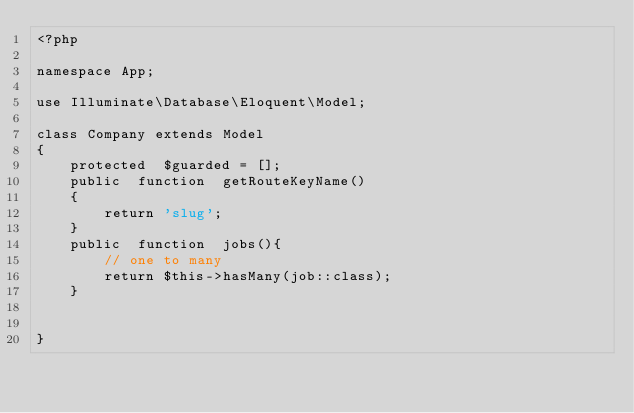Convert code to text. <code><loc_0><loc_0><loc_500><loc_500><_PHP_><?php

namespace App;

use Illuminate\Database\Eloquent\Model;

class Company extends Model
{
    protected  $guarded = [];
    public  function  getRouteKeyName()
    {
        return 'slug';
    }
    public  function  jobs(){
        // one to many
        return $this->hasMany(job::class);
    }


}
</code> 